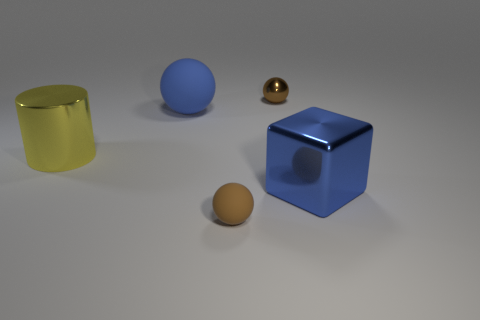Subtract all gray cylinders. How many brown balls are left? 2 Subtract all matte balls. How many balls are left? 1 Add 1 small brown matte things. How many objects exist? 6 Subtract all blocks. How many objects are left? 4 Subtract all big red matte cylinders. Subtract all large metal cubes. How many objects are left? 4 Add 3 large blue metallic objects. How many large blue metallic objects are left? 4 Add 1 small shiny objects. How many small shiny objects exist? 2 Subtract 0 brown cylinders. How many objects are left? 5 Subtract all gray cylinders. Subtract all brown cubes. How many cylinders are left? 1 